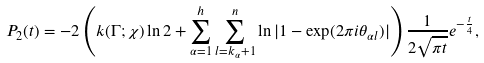<formula> <loc_0><loc_0><loc_500><loc_500>P _ { 2 } ( t ) = - 2 \left ( k ( \Gamma ; \chi ) \ln 2 + \sum _ { \alpha = 1 } ^ { h } \sum _ { l = k _ { \alpha } + 1 } ^ { n } \ln | 1 - \exp ( 2 \pi i \theta _ { \alpha l } ) | \right ) \frac { 1 } { 2 \sqrt { \pi t } } e ^ { - \frac { t } { 4 } } ,</formula> 